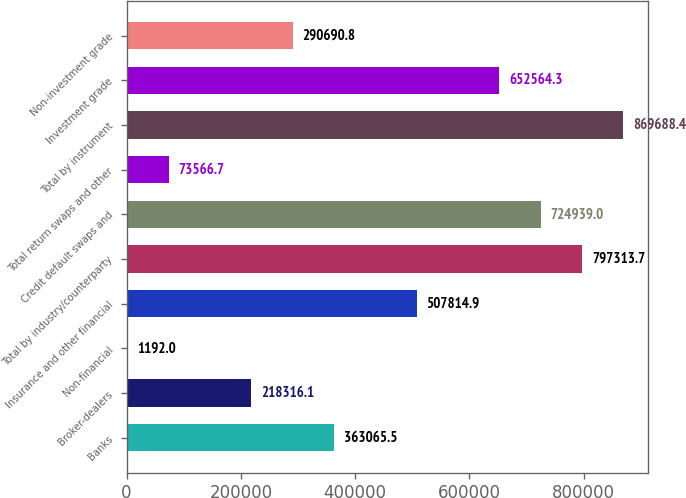<chart> <loc_0><loc_0><loc_500><loc_500><bar_chart><fcel>Banks<fcel>Broker-dealers<fcel>Non-financial<fcel>Insurance and other financial<fcel>Total by industry/counterparty<fcel>Credit default swaps and<fcel>Total return swaps and other<fcel>Total by instrument<fcel>Investment grade<fcel>Non-investment grade<nl><fcel>363066<fcel>218316<fcel>1192<fcel>507815<fcel>797314<fcel>724939<fcel>73566.7<fcel>869688<fcel>652564<fcel>290691<nl></chart> 